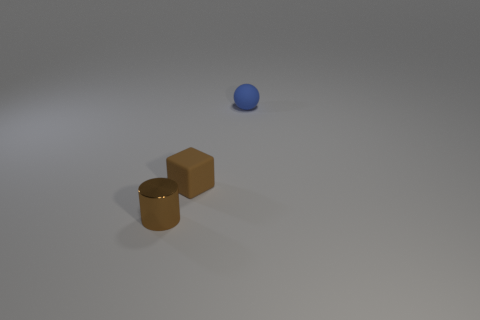There is a block that is the same size as the brown shiny object; what is its color?
Your response must be concise. Brown. Are there any small rubber things of the same shape as the tiny brown metal thing?
Your answer should be very brief. No. There is a brown thing behind the tiny brown object to the left of the matte object in front of the blue thing; what is its material?
Make the answer very short. Rubber. What number of other objects are the same size as the blue thing?
Your answer should be very brief. 2. What is the color of the cube?
Provide a succinct answer. Brown. How many rubber things are either green balls or tiny cylinders?
Make the answer very short. 0. Are there any other things that have the same material as the tiny blue thing?
Offer a very short reply. Yes. There is a rubber object that is in front of the matte thing that is behind the matte thing that is in front of the tiny blue thing; what size is it?
Your response must be concise. Small. How big is the object that is both to the left of the blue matte ball and to the right of the small brown cylinder?
Give a very brief answer. Small. There is a thing that is in front of the tiny rubber block; does it have the same color as the tiny rubber thing in front of the tiny matte sphere?
Provide a succinct answer. Yes. 